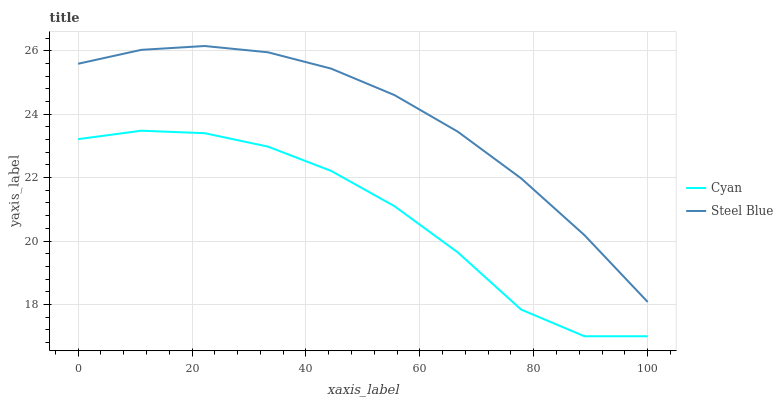Does Cyan have the minimum area under the curve?
Answer yes or no. Yes. Does Steel Blue have the maximum area under the curve?
Answer yes or no. Yes. Does Steel Blue have the minimum area under the curve?
Answer yes or no. No. Is Steel Blue the smoothest?
Answer yes or no. Yes. Is Cyan the roughest?
Answer yes or no. Yes. Is Steel Blue the roughest?
Answer yes or no. No. Does Cyan have the lowest value?
Answer yes or no. Yes. Does Steel Blue have the lowest value?
Answer yes or no. No. Does Steel Blue have the highest value?
Answer yes or no. Yes. Is Cyan less than Steel Blue?
Answer yes or no. Yes. Is Steel Blue greater than Cyan?
Answer yes or no. Yes. Does Cyan intersect Steel Blue?
Answer yes or no. No. 